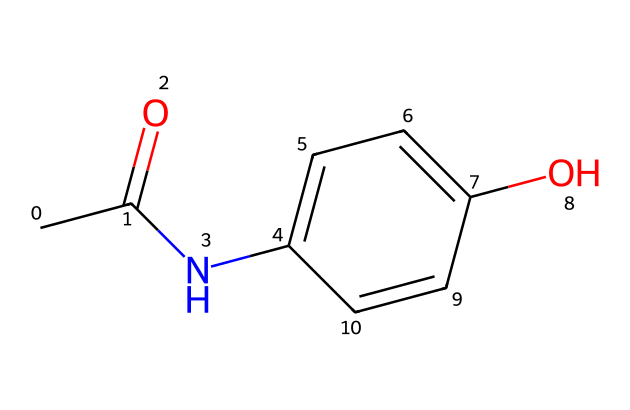What is the molecular formula of acetaminophen? The molecular formula can be deduced from the provided SMILES representation. Counting the number of each type of atom, we find that there are 8 carbon atoms, 9 hydrogen atoms, 1 nitrogen atom, and 1 oxygen atom. Thus, the molecular formula is C8H9NO2.
Answer: C8H9NO2 How many hydrogen atoms are present in acetaminophen? By analyzing the SMILES structure, we can count the hydrogen atoms attached to each carbon and nitrogen atom. There are a total of 9 hydrogen atoms in the molecule.
Answer: 9 What functional groups are present in this molecule? The SMILES structure indicates the presence of an amide group (CC(=O)N), a hydroxy group (OH), and a ketone group (C=O). This tells us that acetaminophen contains at least these three functional groups.
Answer: amide, hydroxy, ketone Is acetaminophen likely to be polar or nonpolar? The presence of polar functional groups, especially the hydroxy and amide groups, suggests that acetaminophen is polar. The molecule has regions that can form hydrogen bonds, leading to higher solubility in water.
Answer: polar What type of drug is acetaminophen considered? Acetaminophen acts primarily as an analgesic and antipyretic, which means it is used to relieve pain and reduce fever. The presence of its structure indicates these properties.
Answer: analgesic and antipyretic How does the structural arrangement of acetaminophen contribute to its pain-relieving properties? The arrangement allows for interaction with pain receptors by mimicking the structures that those receptors respond to. The presence of the amide bond and hydroxy groups plays a crucial role in drug-receptor interactions.
Answer: mimics receptor structures 